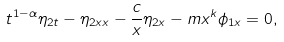<formula> <loc_0><loc_0><loc_500><loc_500>t ^ { 1 - \alpha } \eta _ { 2 t } - \eta _ { 2 x x } - \frac { c } { x } \eta _ { 2 x } - m x ^ { k } \phi _ { 1 x } = 0 ,</formula> 